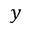Convert formula to latex. <formula><loc_0><loc_0><loc_500><loc_500>y</formula> 